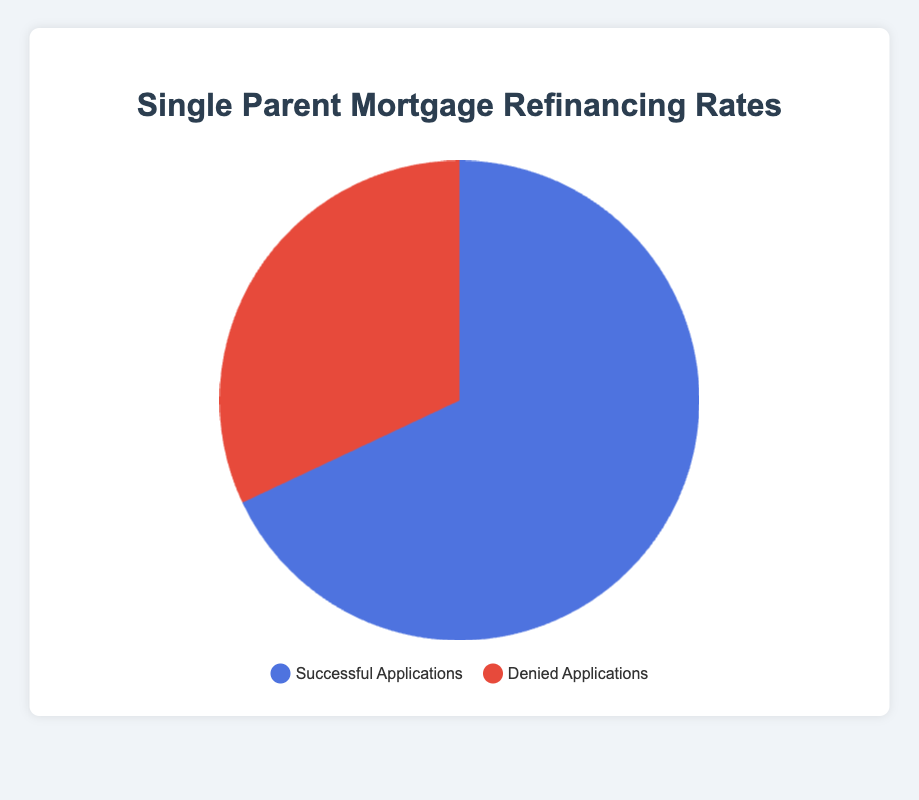What's the percentage of successful refinancing applications? The pie chart displays two segments: Successful Applications and Denied Applications. The successful applications are labeled with a percentage.
Answer: 68% Which type of applications has a higher percentage, successful or denied? By comparing the two segments in the pie chart, the Successful Applications section is larger than the Denied Applications section.
Answer: Successful Applications What is the difference in percentage between successful and denied refinancing applications? The percentage for successful applications is 68%, and for denied applications, it is 32%. The difference is calculated by subtracting 32% from 68%.
Answer: 36% What is the sum of the percentages of successful and denied applications? Since the pie chart represents the total distribution of applications, the sum of the percentages of all segments should be 100%.
Answer: 100% Which color represents the successful applications on the pie chart? The legend below the pie chart indicates which color corresponds to each segment. The Successful Applications section is blue.
Answer: Blue Which lender has the highest approval rate for refinancing applications? Reviewing the details provided about lender approval rates, Bank of America has the highest approval rate at 72%.
Answer: Bank of America What is the average approval rate across all the lenders? The details provide the following approval rates: Chase Bank (70%), Wells Fargo (65%), Bank of America (72%), Citibank (66%). Calculating the average involves summing these rates and dividing by the number of lenders: (70 + 65 + 72 + 66) / 4 = 68.25%.
Answer: 68.25% Which lender has the lowest denial rate, and what is it? From the details, the denial rates are: Chase Bank (30%), Wells Fargo (35%), Bank of America (28%), Citibank (34%). The lowest denial rate is 28% from Bank of America.
Answer: Bank of America If the total number of applications is 500, how many were denied? If the total number of applications is 500 and 32% are denied, then the number of denied applications is 32% of 500. Calculated as (32/100) * 500 = 160.
Answer: 160 